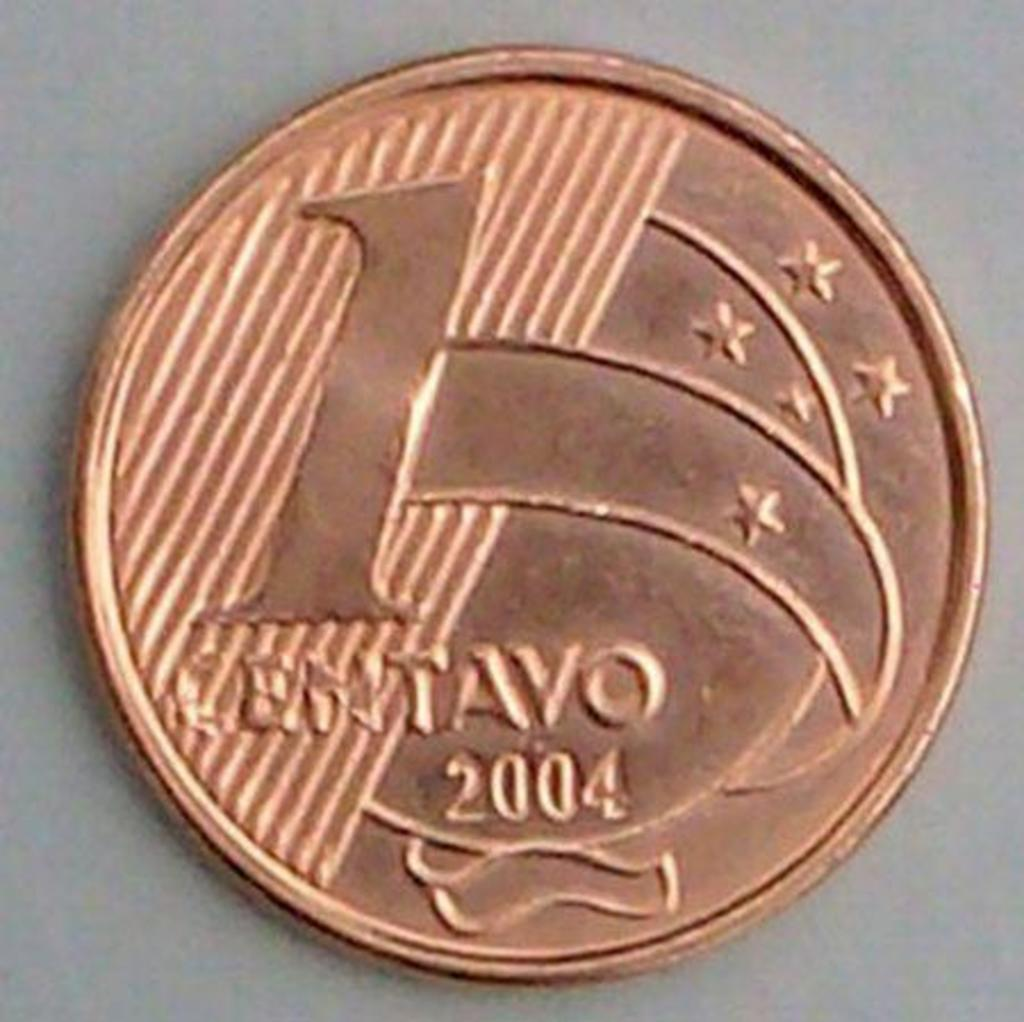<image>
Share a concise interpretation of the image provided. A bronze coin worth 1 cent is on a surface. 